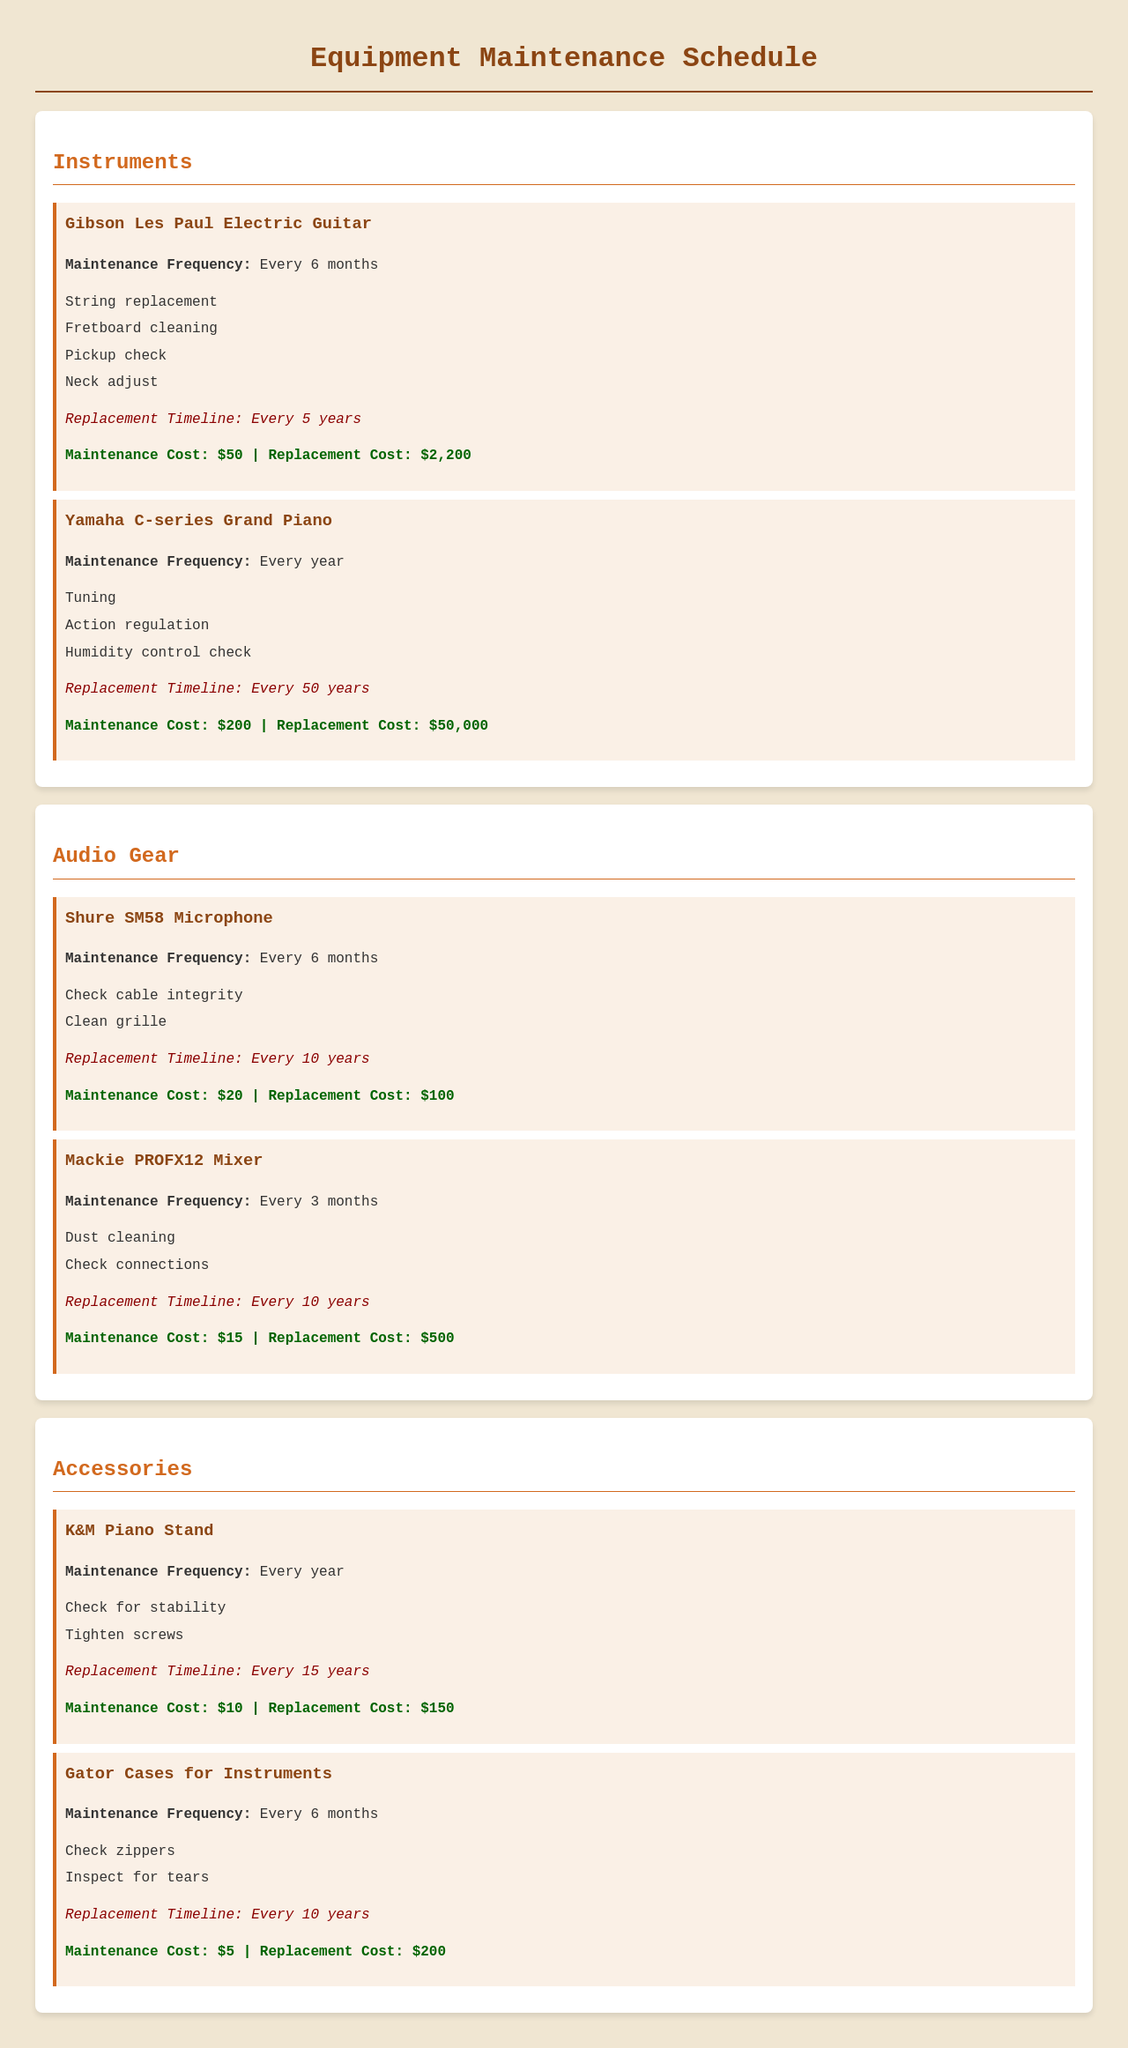What is the maintenance frequency for the Yamaha C-series Grand Piano? The maintenance frequency for the Yamaha C-series Grand Piano is mentioned in the document as every year.
Answer: Every year What is the replacement cost of the Shure SM58 Microphone? The replacement cost of the Shure SM58 Microphone is specifically listed in the document.
Answer: $100 How often should the K&M Piano Stand be maintained? The document states that the K&M Piano Stand should be maintained every year.
Answer: Every year What is the total maintenance cost for the Gibson Les Paul Electric Guitar? The maintenance cost for the Gibson Les Paul Electric Guitar is provided as $50.
Answer: $50 How many years is the replacement timeline for the Yamaha C-series Grand Piano? The replacement timeline for the Yamaha C-series Grand Piano is detailed in the document as every 50 years.
Answer: Every 50 years Which audio gear requires maintenance every 3 months? By checking the maintenance frequency in the document, we can identify which audio gear requires this frequency of maintenance.
Answer: Mackie PROFX12 Mixer What type of maintenance does the Gator Cases for Instruments require? The document lists specific maintenance tasks for the Gator Cases for Instruments.
Answer: Check zippers, Inspect for tears What is the total replacement cost for the instruments listed? To determine the total replacement cost, we sum the replacement costs of all instruments mentioned in the document: $2,200 + $50,000 + $100 + $500 + $150 + $200.
Answer: $52,200 How often do you need to replace the Mackie PROFX12 Mixer? The document provides information on the replacement timeline for the Mackie PROFX12 Mixer.
Answer: Every 10 years 